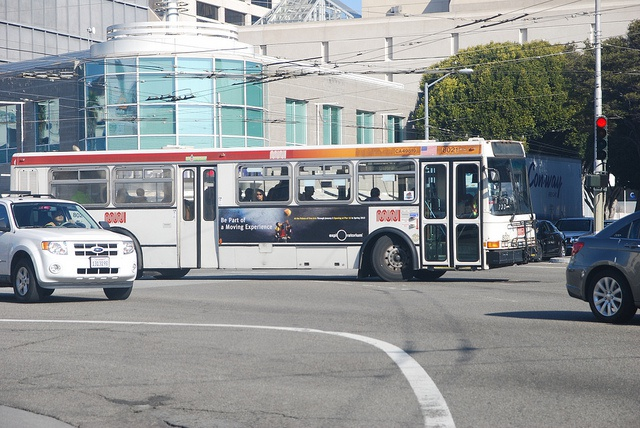Describe the objects in this image and their specific colors. I can see bus in darkgray, lightgray, gray, and black tones, car in darkgray, white, black, gray, and navy tones, car in darkgray, black, navy, darkblue, and gray tones, car in darkgray, black, gray, and darkblue tones, and car in darkgray, black, blue, navy, and gray tones in this image. 